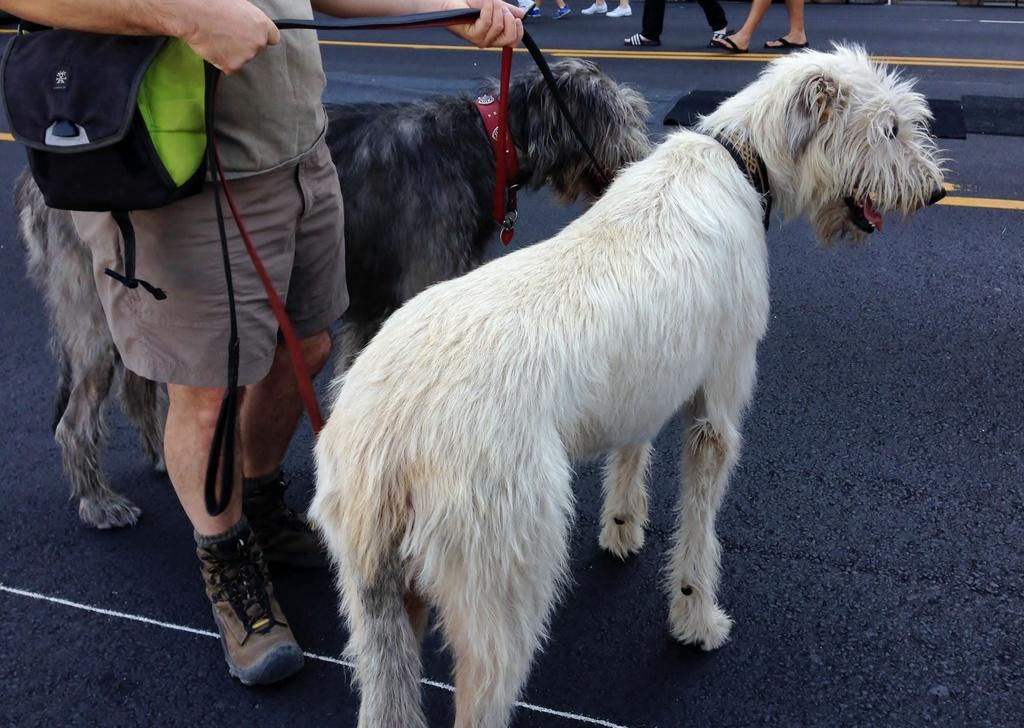What is the person holding in the image? The person is holding belts in the image. What are the belts attached to? The belts are tied to dogs. What part of the people can be seen in the image? People's legs are visible at the top of the image. What else does the person holding the belts have? The person holding the belts has a bag. How does the person adjust the door in the image? There is no door present in the image; it features a person holding belts tied to dogs. 